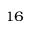<formula> <loc_0><loc_0><loc_500><loc_500>^ { 1 6 }</formula> 